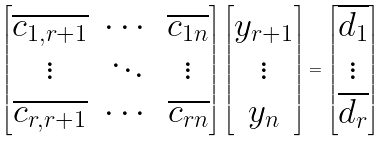<formula> <loc_0><loc_0><loc_500><loc_500>\begin{bmatrix} \overline { c _ { 1 , r + 1 } } & \cdots & \overline { c _ { 1 n } } \\ \vdots & \ddots & \vdots \\ \overline { c _ { r , r + 1 } } & \cdots & \overline { c _ { r n } } \end{bmatrix} \begin{bmatrix} y _ { r + 1 } \\ \vdots \\ y _ { n } \end{bmatrix} = \begin{bmatrix} \overline { d _ { 1 } } \\ \vdots \\ \overline { d _ { r } } \end{bmatrix}</formula> 